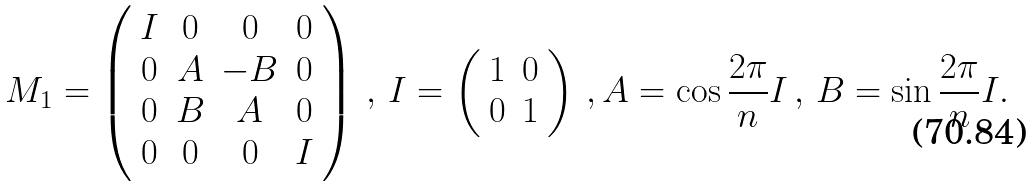Convert formula to latex. <formula><loc_0><loc_0><loc_500><loc_500>M _ { 1 } = \left ( \begin{array} { c c c c } { I } & { 0 } & { 0 } & { 0 } \\ { 0 } & { A } & { - B } & { 0 } \\ { 0 } & { B } & { A } & { 0 } \\ { 0 } & { 0 } & { 0 } & { I } \end{array} \right ) \, , \, I = \left ( \begin{array} { c c } { 1 } & { 0 } \\ { 0 } & { 1 } \end{array} \right ) \, , A = \cos \frac { 2 \pi } { n } I \, , \, B = \sin \frac { 2 \pi } { n } I .</formula> 